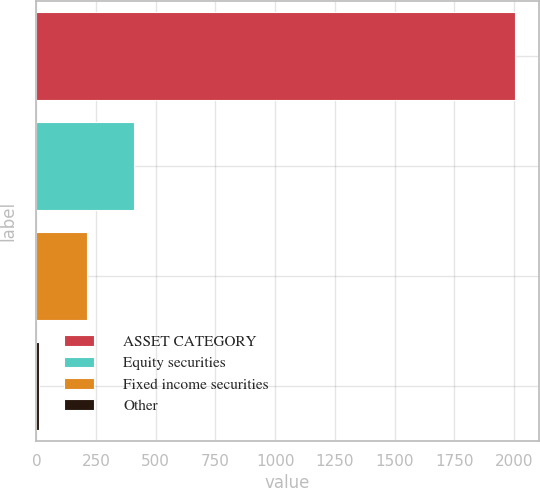Convert chart. <chart><loc_0><loc_0><loc_500><loc_500><bar_chart><fcel>ASSET CATEGORY<fcel>Equity securities<fcel>Fixed income securities<fcel>Other<nl><fcel>2003<fcel>410.2<fcel>211.1<fcel>12<nl></chart> 